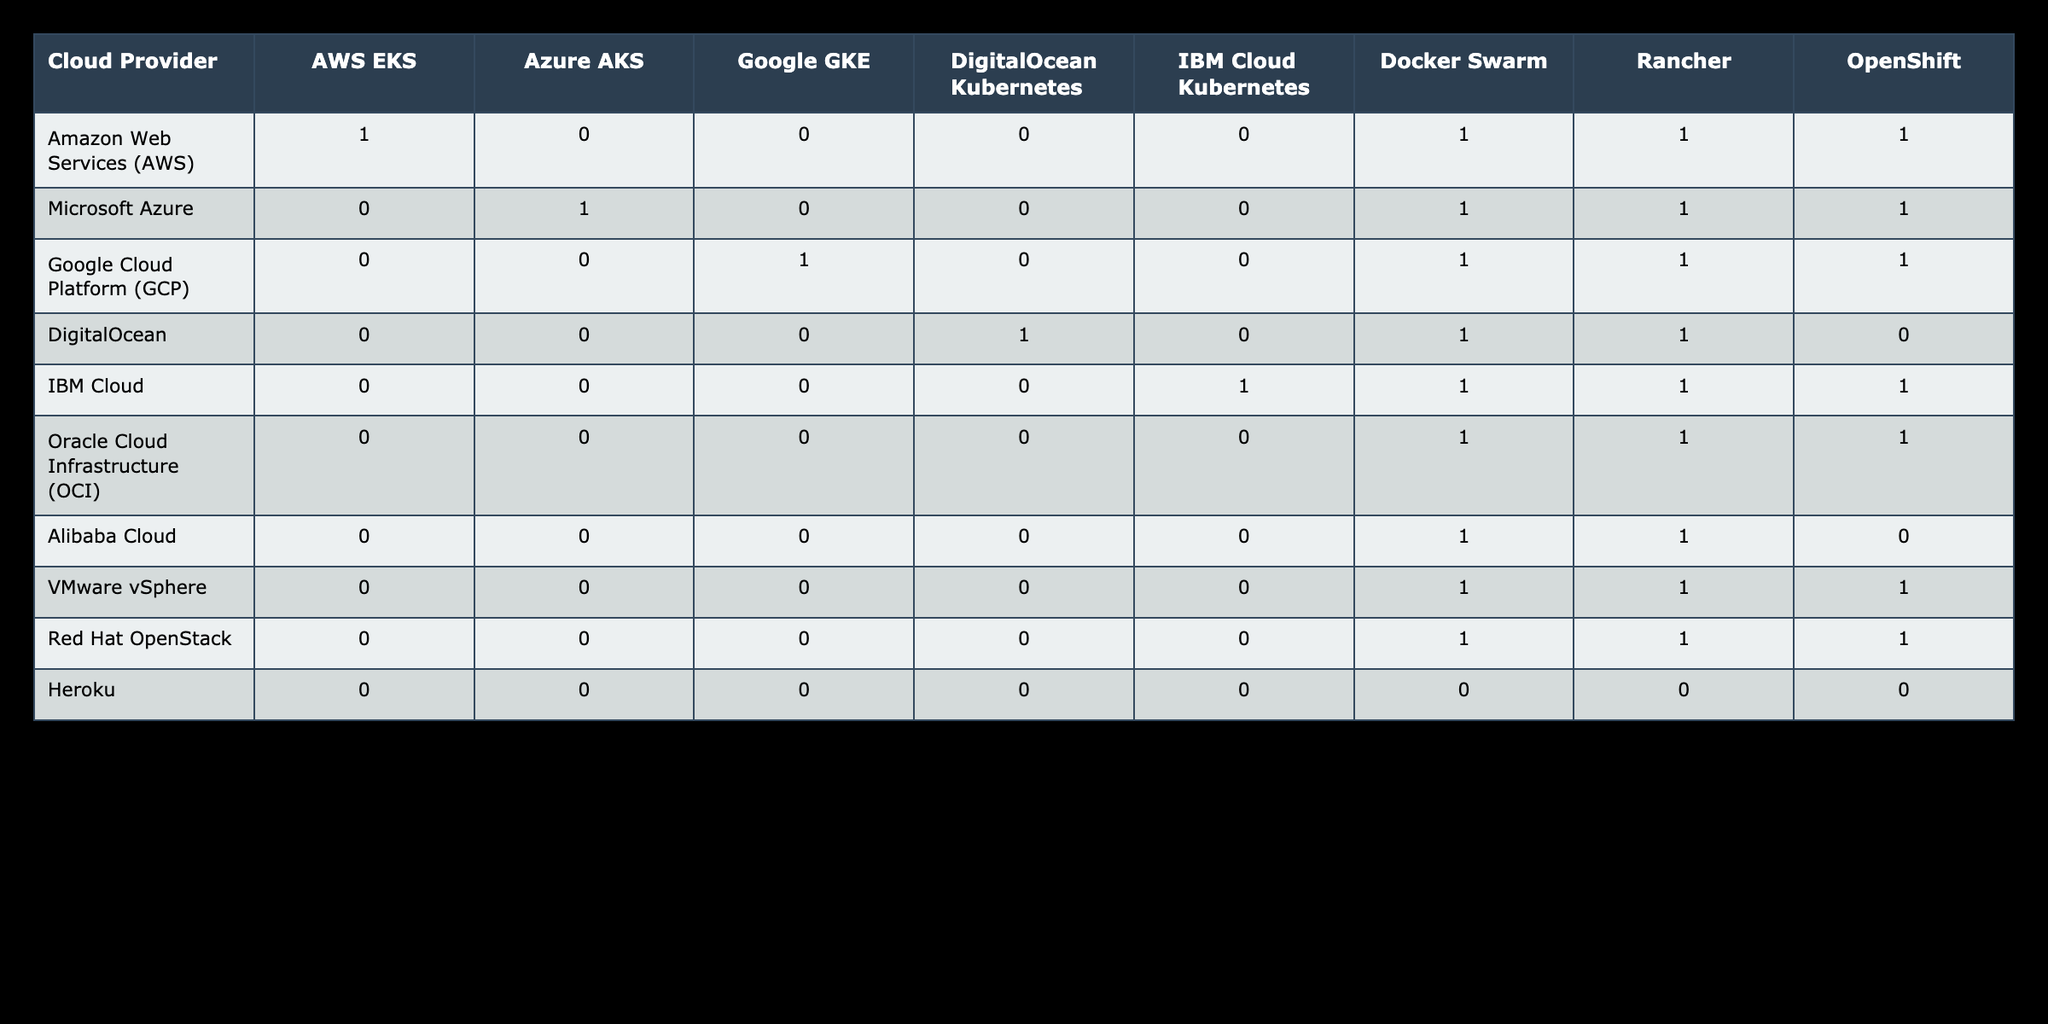What cloud provider is compatible with Docker Swarm? From the table, Docker Swarm is compatible with several cloud providers. By looking at the Docker Swarm column, we can see that Amazon Web Services (AWS), Microsoft Azure, Google Cloud Platform (GCP), DigitalOcean, IBM Cloud, Oracle Cloud Infrastructure (OCI), Alibaba Cloud, VMware vSphere, and Red Hat OpenStack all have a value of 1, indicating compatibility.
Answer: AWS, Azure, GCP, DigitalOcean, IBM Cloud, OCI, Alibaba, VMware, Red Hat Which container orchestration tool is supported by all cloud providers listed? By examining the table, we notice that the column corresponding to each cloud provider does not show any container orchestration tool that has a value of 1 consistently across all providers. Specifically, Docker Swarm and Rancher show compatibility with most but not all, and a few providers have values of 0 for every tool. Thus, there is no orchestration tool supported by all.
Answer: None How many container orchestration tools does IBM Cloud Kubernetes support? According to the IBM Cloud Kubernetes row, the supported container orchestration tools marked with a value of 1 are Docker Swarm, Rancher, and OpenShift, making a total of 3 supported tools.
Answer: 3 Is Google GKE compatible with DigitalOcean? By checking the compatibility between Google GKE and DigitalOcean, we find that in the intersection of the row for Google Cloud Platform and the column for DigitalOcean, the value is 0. This indicates that Google GKE is not compatible with DigitalOcean.
Answer: No Which cloud provider has the highest number of supported container orchestration tools? By reviewing the table, we can see that cloud providers like AWS EKS, Azure AKS, Google GKE, and others are associated with various orchestration tools. Counting the number of 1s in each row reveals that the maximum count occurs for IBM Cloud, which supports 4 tools (Docker Swarm, Rancher, OpenShift, and itself). Thus, IBM Cloud has the highest number of supported tools.
Answer: IBM Cloud Which container orchestration tool is supported by both AWS and Azure, but not by DigitalOcean? Looking at the columns for AWS EKS and Azure AKS, we find that both support tools like Docker Swarm, Rancher, and OpenShift. Checking the DigitalOcean column, we find it does not support OpenShift (which is compatible with both AWS and Azure) as it has a value of 0 for this tool. Therefore, the answer is OpenShift.
Answer: OpenShift How many cloud providers are compatible with Rancher? To determine this, we count the number of 1s in the Rancher column. By viewing the column, we see that Rancher is compatible with AWS, Azure, GCP, DigitalOcean, IBM Cloud, OCI, Alibaba Cloud, VMware, and Red Hat OpenStack, totaling 8 cloud providers.
Answer: 8 